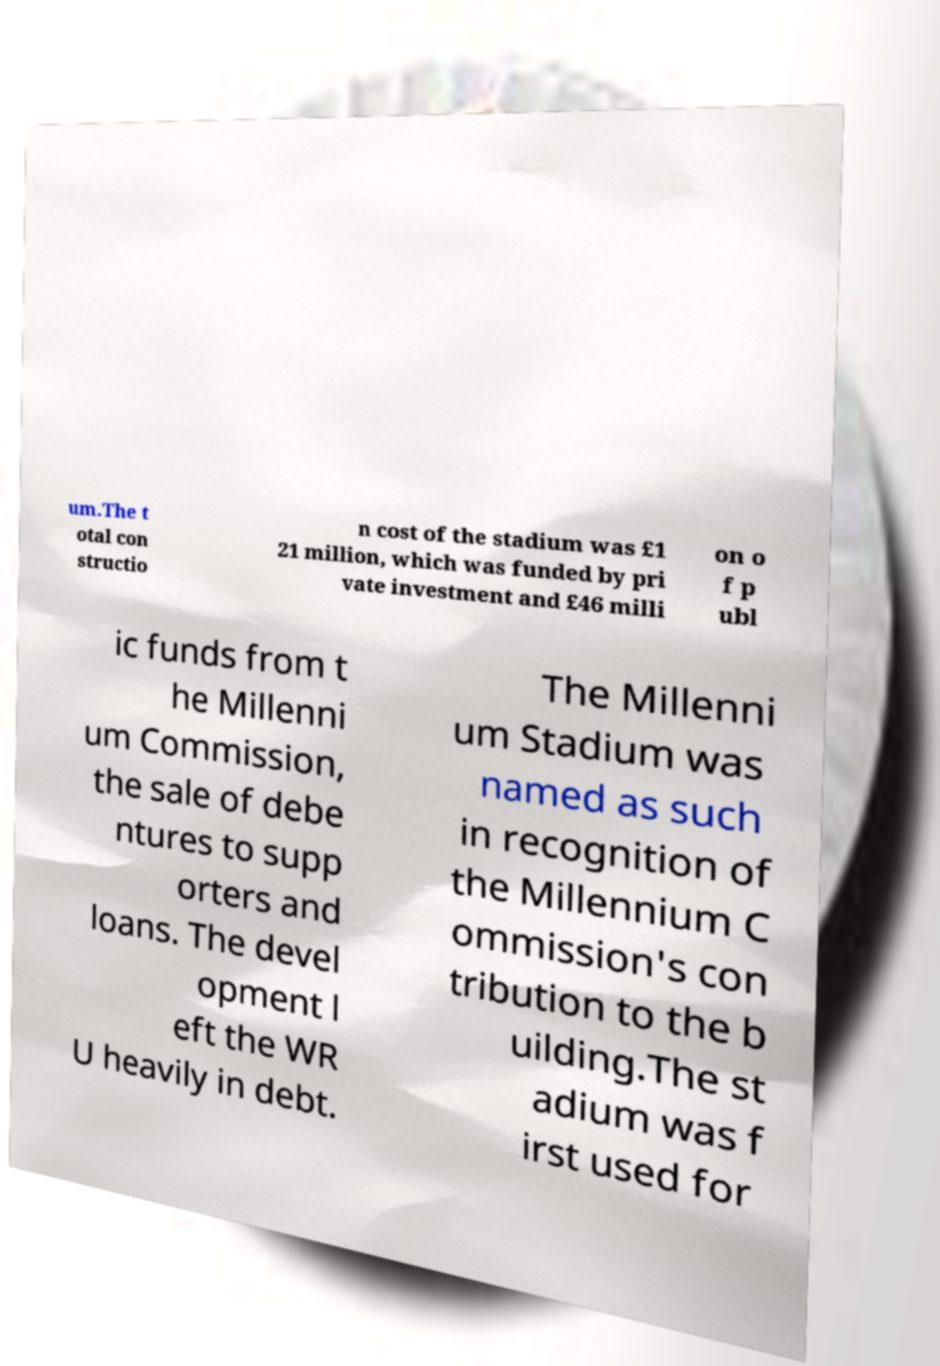Can you read and provide the text displayed in the image?This photo seems to have some interesting text. Can you extract and type it out for me? um.The t otal con structio n cost of the stadium was £1 21 million, which was funded by pri vate investment and £46 milli on o f p ubl ic funds from t he Millenni um Commission, the sale of debe ntures to supp orters and loans. The devel opment l eft the WR U heavily in debt. The Millenni um Stadium was named as such in recognition of the Millennium C ommission's con tribution to the b uilding.The st adium was f irst used for 